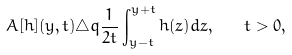Convert formula to latex. <formula><loc_0><loc_0><loc_500><loc_500>A [ h ] ( y , t ) \triangle q \frac { 1 } { 2 t } \int _ { y - t } ^ { y + t } h ( z ) d z , \quad t > 0 ,</formula> 